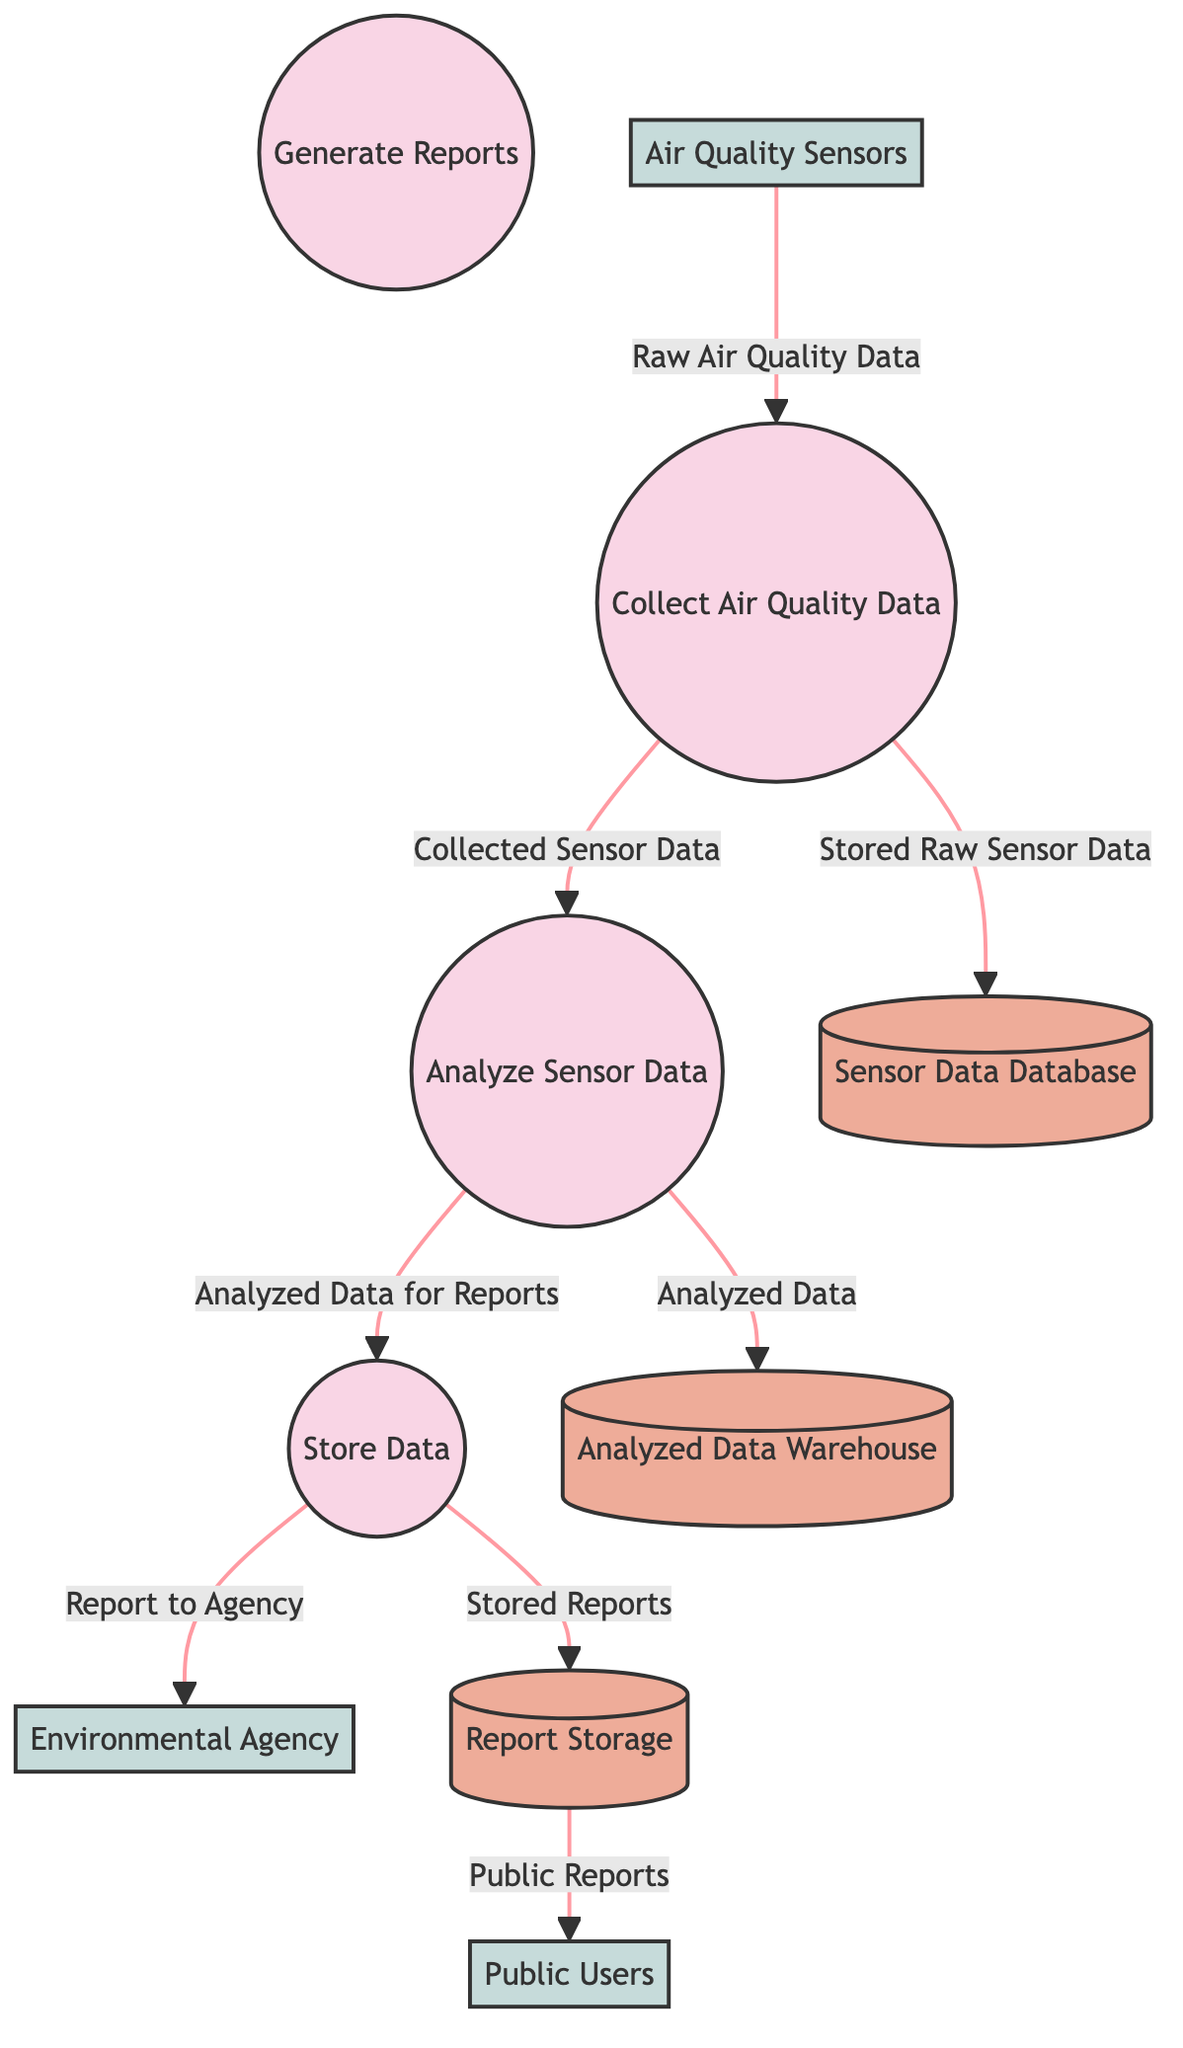What is the first process in the diagram? The first process listed in the diagram is "Collect Air Quality Data," which corresponds to the identifier "1."
Answer: Collect Air Quality Data How many data stores are present in the system? The diagram lists a total of three data stores: "Sensor Data Database," "Analyzed Data Warehouse," and "Report Storage."
Answer: 3 Which external entity is responsible for accessing public air quality reports? The external entity responsible for accessing public air quality reports is "Public Users," which corresponds to the identifier "E3."
Answer: Public Users What type of data flows from the "Analyze Sensor Data" process to the data store? The data flowing from "Analyze Sensor Data" to a data store is "Analyzed Data," which is directed towards the "Analyzed Data Warehouse."
Answer: Analyzed Data Which process generates reports for the Environmental Agency? The process that generates reports for the Environmental Agency is "Store Data," which sends the output "Report to Agency" directly to the external entity "Environmental Agency."
Answer: Store Data What relationship exists between "Collect Air Quality Data" and the "Sensor Data Database"? The relationship is that the "Collect Air Quality Data" process outputs "Stored Raw Sensor Data," which is then stored in the "Sensor Data Database."
Answer: Outputs to What is the direct output of the "Store Data" process? The direct outputs of the "Store Data" process are "Stored Reports," which go to the "Report Storage," and "Report to Agency," which goes to "Environmental Agency."
Answer: Stored Reports, Report to Agency How many processes analyze data before it is stored? There is one process that analyzes data before it is stored, which is the "Analyze Sensor Data" process.
Answer: 1 What type of data flows to the public users? The type of data that flows to the public users is "Public Reports," which is stored in the "Report Storage."
Answer: Public Reports 